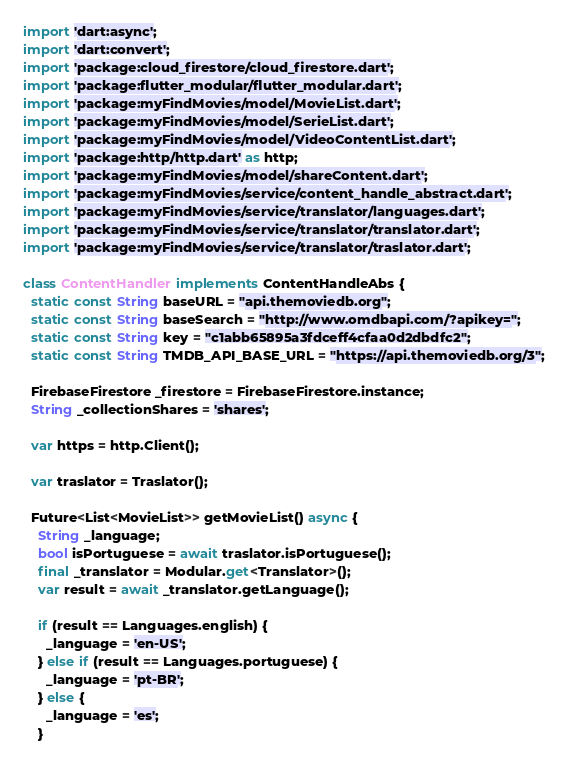Convert code to text. <code><loc_0><loc_0><loc_500><loc_500><_Dart_>import 'dart:async';
import 'dart:convert';
import 'package:cloud_firestore/cloud_firestore.dart';
import 'package:flutter_modular/flutter_modular.dart';
import 'package:myFindMovies/model/MovieList.dart';
import 'package:myFindMovies/model/SerieList.dart';
import 'package:myFindMovies/model/VideoContentList.dart';
import 'package:http/http.dart' as http;
import 'package:myFindMovies/model/shareContent.dart';
import 'package:myFindMovies/service/content_handle_abstract.dart';
import 'package:myFindMovies/service/translator/languages.dart';
import 'package:myFindMovies/service/translator/translator.dart';
import 'package:myFindMovies/service/translator/traslator.dart';

class ContentHandler implements ContentHandleAbs {
  static const String baseURL = "api.themoviedb.org";
  static const String baseSearch = "http://www.omdbapi.com/?apikey=";
  static const String key = "c1abb65895a3fdceff4cfaa0d2dbdfc2";
  static const String TMDB_API_BASE_URL = "https://api.themoviedb.org/3";

  FirebaseFirestore _firestore = FirebaseFirestore.instance;
  String _collectionShares = 'shares';

  var https = http.Client();

  var traslator = Traslator();

  Future<List<MovieList>> getMovieList() async {
    String _language;
    bool isPortuguese = await traslator.isPortuguese();
    final _translator = Modular.get<Translator>();
    var result = await _translator.getLanguage();

    if (result == Languages.english) {
      _language = 'en-US';
    } else if (result == Languages.portuguese) {
      _language = 'pt-BR';
    } else {
      _language = 'es';
    }
</code> 